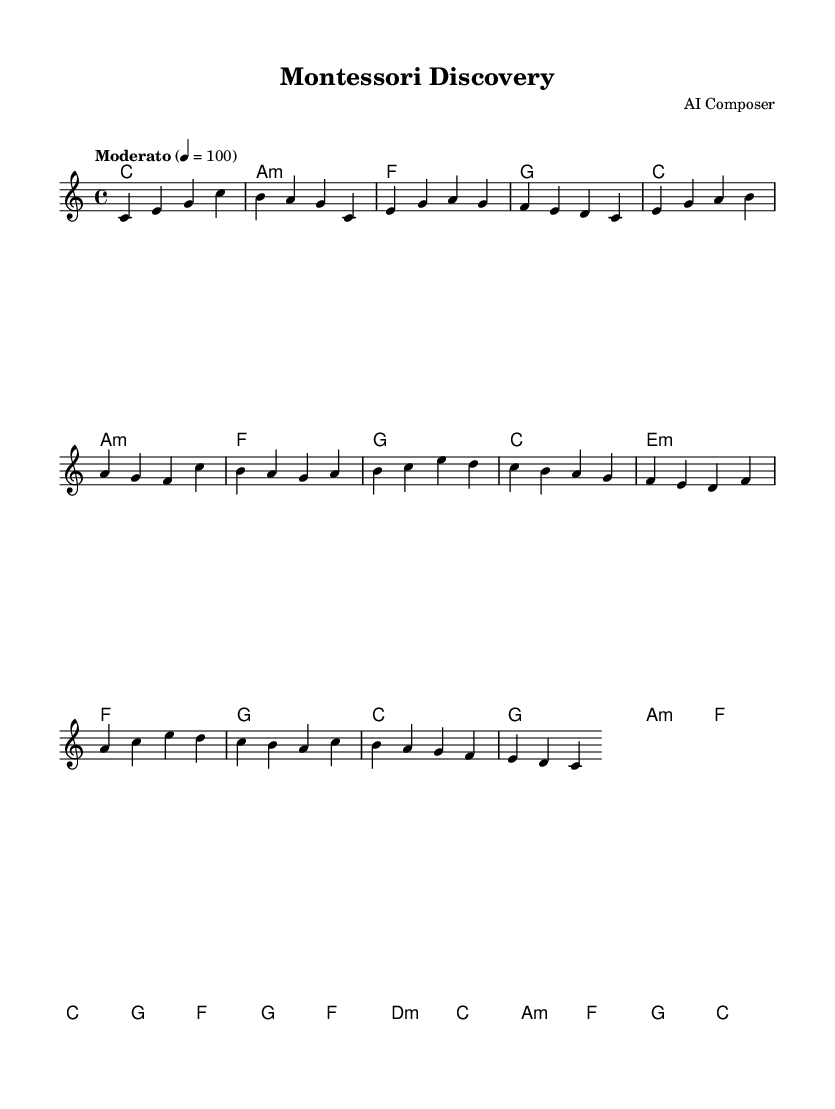What is the key signature of this music? The key signature is indicated by the absence of sharps or flats at the beginning of the staff, which corresponds to C major.
Answer: C major What is the time signature of this music? The time signature is shown at the beginning of the piece as "4/4", indicating four beats per measure.
Answer: 4/4 What is the tempo marking for this music? The tempo marking at the start indicates a "Moderato" tempo, which typically means a moderate pace.
Answer: Moderato How many measures are in the introduction? The introduction spans four measures, with each measure containing a distinct set of notes.
Answer: 4 What is the first chord played in the music? The first chord is identified in the chord progression at the start and is marked by "c1".
Answer: C major In which section does the bridge occur? The bridge is found after the chorus section, as it features different harmonies and is labeled explicitly in the score.
Answer: Bridge 